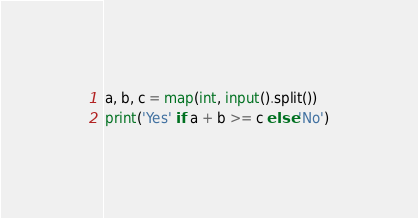<code> <loc_0><loc_0><loc_500><loc_500><_Python_>a, b, c = map(int, input().split())
print('Yes' if a + b >= c else 'No')</code> 